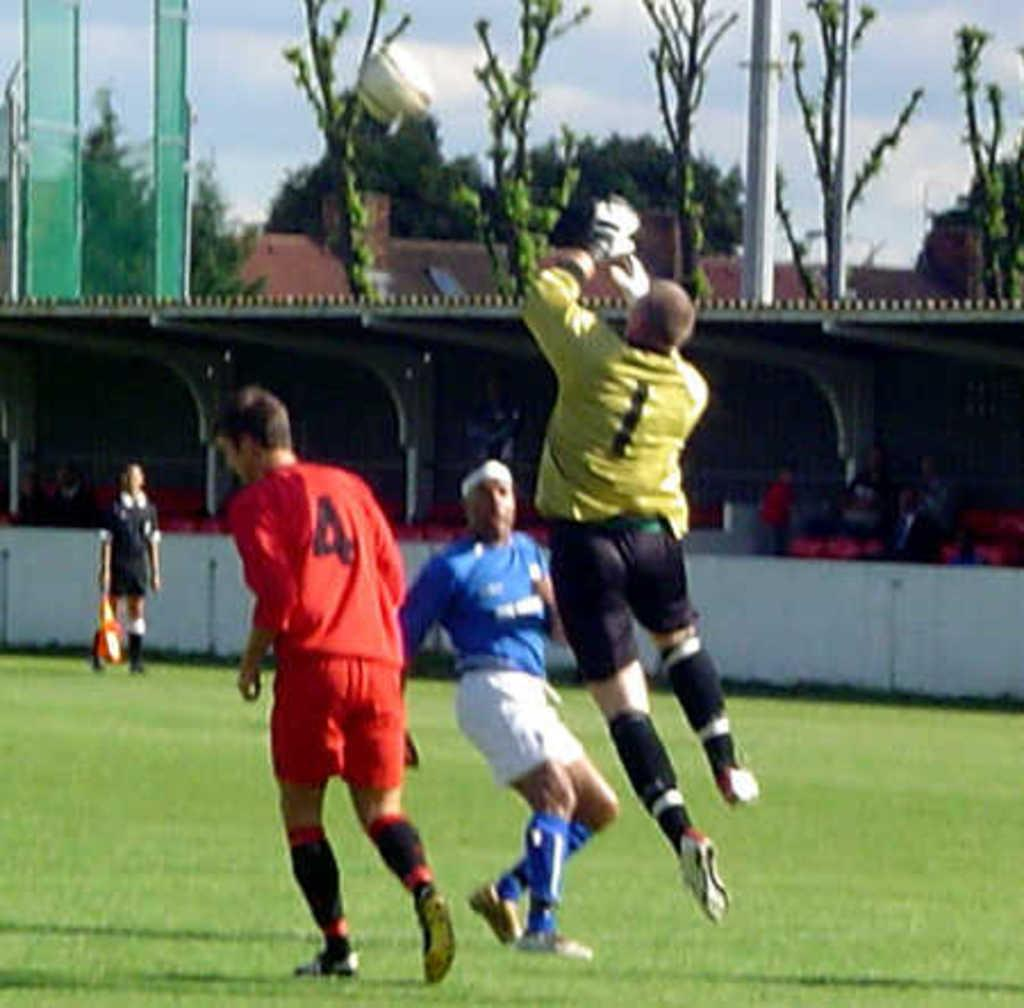<image>
Describe the image concisely. a few players with one that has the number 4 on them 